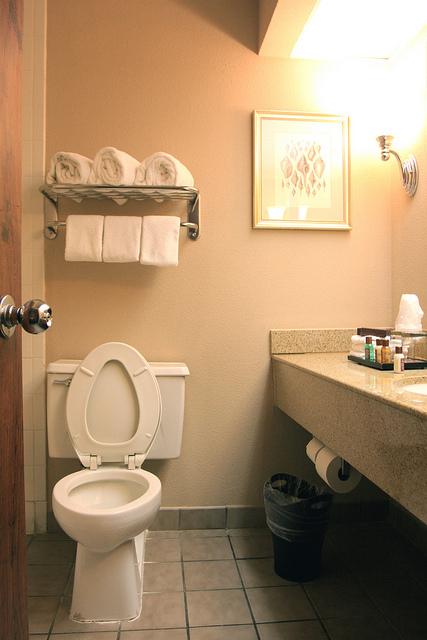Where are the towels?
Keep it brief. Above toilet. How many rolls of toilet paper are there?
Answer briefly. 2. Where is the towel?
Short answer required. Above toilet. Does the bathroom look clean?
Keep it brief. Yes. Is the toilet lid down?
Give a very brief answer. No. 